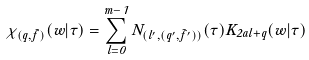Convert formula to latex. <formula><loc_0><loc_0><loc_500><loc_500>\chi _ { ( q , \tilde { f } ) } ( w | \tau ) = \sum _ { l = 0 } ^ { m - 1 } N _ { { ( l ^ { \prime } , ( q ^ { \prime } , \tilde { f } ^ { \prime } ) ) } } ( \tau ) K _ { 2 a l + q } ( w | \tau )</formula> 